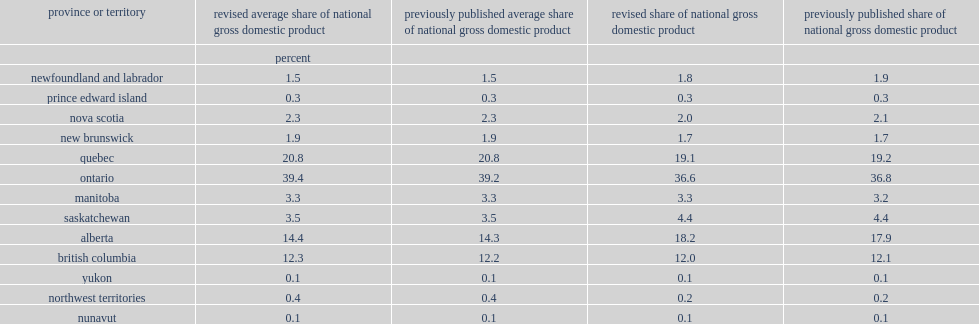What was the percentage of the total national gross domestic product ontario accounted for? 39.4. Which province or territory accounted for the largest share of national gross domestic product? Ontario. Which province or territory accounted for the second largest share of national gross domestic product? Quebec. Which province or territory accounted for the third largest share of national gross domestic product? Alberta. 